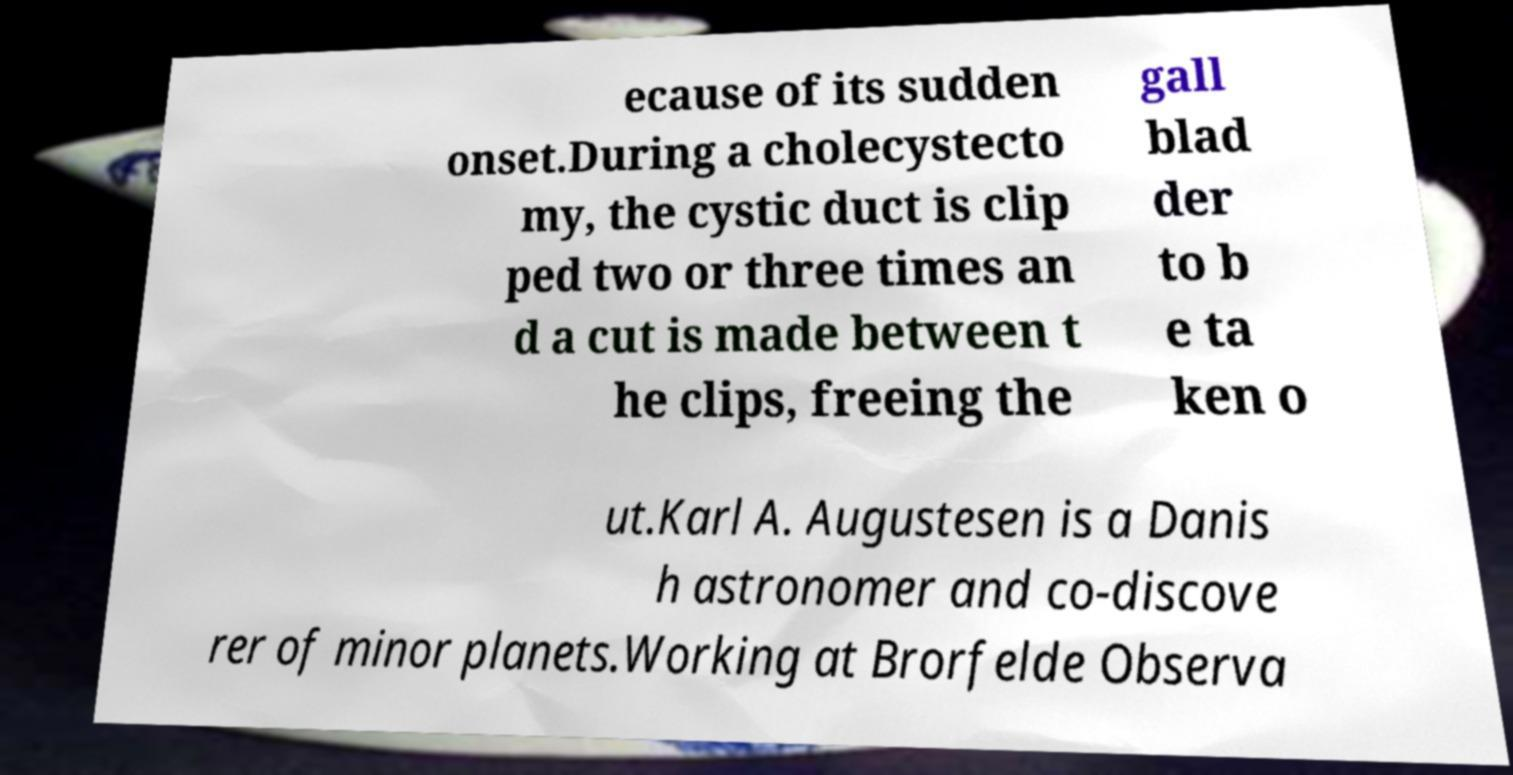What messages or text are displayed in this image? I need them in a readable, typed format. ecause of its sudden onset.During a cholecystecto my, the cystic duct is clip ped two or three times an d a cut is made between t he clips, freeing the gall blad der to b e ta ken o ut.Karl A. Augustesen is a Danis h astronomer and co-discove rer of minor planets.Working at Brorfelde Observa 